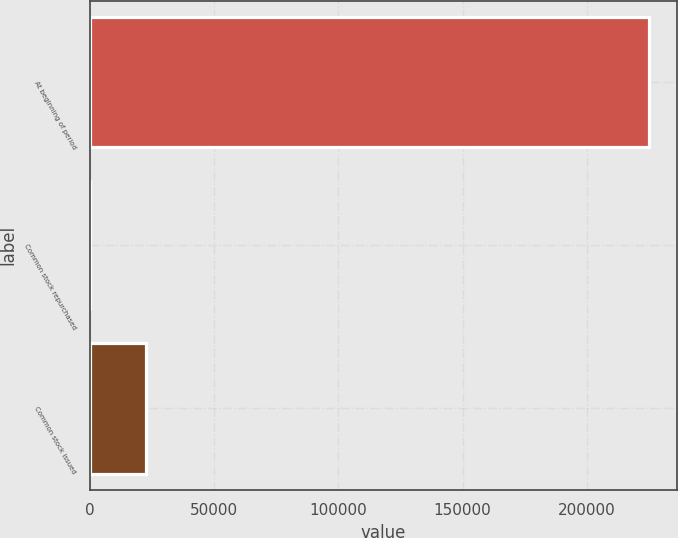Convert chart. <chart><loc_0><loc_0><loc_500><loc_500><bar_chart><fcel>At beginning of period<fcel>Common stock repurchased<fcel>Common stock issued<nl><fcel>225146<fcel>38<fcel>22548.8<nl></chart> 